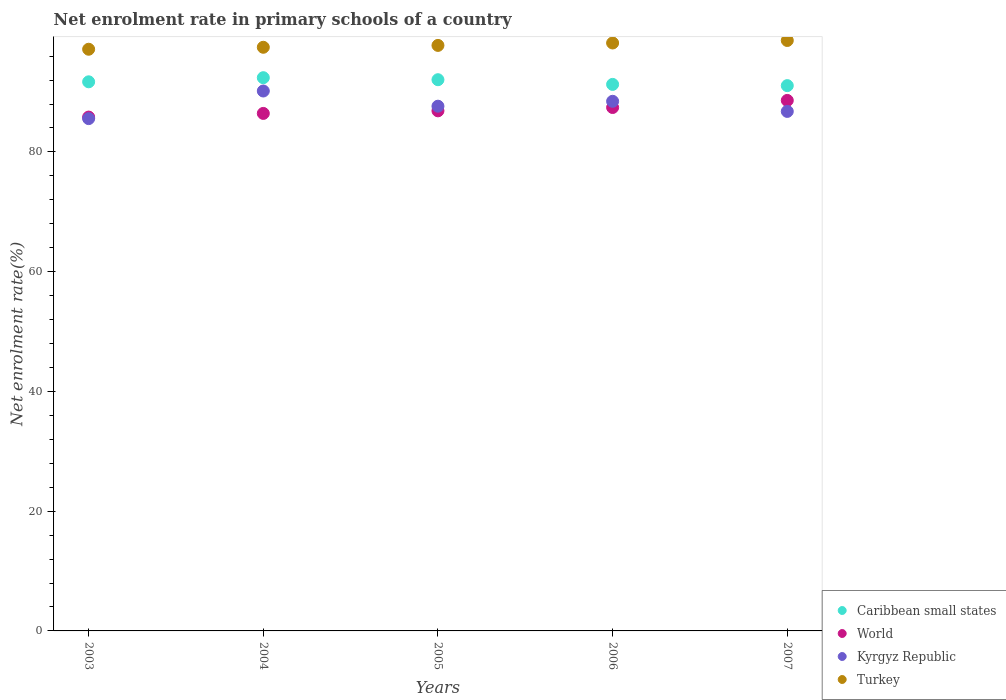How many different coloured dotlines are there?
Your answer should be compact. 4. Is the number of dotlines equal to the number of legend labels?
Provide a short and direct response. Yes. What is the net enrolment rate in primary schools in World in 2004?
Offer a terse response. 86.43. Across all years, what is the maximum net enrolment rate in primary schools in World?
Your answer should be very brief. 88.6. Across all years, what is the minimum net enrolment rate in primary schools in Kyrgyz Republic?
Give a very brief answer. 85.56. What is the total net enrolment rate in primary schools in World in the graph?
Offer a very short reply. 435.12. What is the difference between the net enrolment rate in primary schools in World in 2006 and that in 2007?
Offer a very short reply. -1.18. What is the difference between the net enrolment rate in primary schools in Kyrgyz Republic in 2003 and the net enrolment rate in primary schools in World in 2007?
Make the answer very short. -3.04. What is the average net enrolment rate in primary schools in Caribbean small states per year?
Ensure brevity in your answer.  91.7. In the year 2006, what is the difference between the net enrolment rate in primary schools in Turkey and net enrolment rate in primary schools in World?
Offer a very short reply. 10.78. What is the ratio of the net enrolment rate in primary schools in Caribbean small states in 2004 to that in 2007?
Keep it short and to the point. 1.01. What is the difference between the highest and the second highest net enrolment rate in primary schools in Kyrgyz Republic?
Offer a terse response. 1.72. What is the difference between the highest and the lowest net enrolment rate in primary schools in Caribbean small states?
Your response must be concise. 1.33. In how many years, is the net enrolment rate in primary schools in World greater than the average net enrolment rate in primary schools in World taken over all years?
Your answer should be very brief. 2. Is it the case that in every year, the sum of the net enrolment rate in primary schools in Caribbean small states and net enrolment rate in primary schools in Turkey  is greater than the net enrolment rate in primary schools in Kyrgyz Republic?
Provide a short and direct response. Yes. Does the net enrolment rate in primary schools in Caribbean small states monotonically increase over the years?
Provide a short and direct response. No. Is the net enrolment rate in primary schools in Turkey strictly greater than the net enrolment rate in primary schools in Kyrgyz Republic over the years?
Your response must be concise. Yes. Is the net enrolment rate in primary schools in Caribbean small states strictly less than the net enrolment rate in primary schools in World over the years?
Provide a succinct answer. No. How many years are there in the graph?
Offer a very short reply. 5. What is the difference between two consecutive major ticks on the Y-axis?
Keep it short and to the point. 20. Where does the legend appear in the graph?
Provide a short and direct response. Bottom right. How are the legend labels stacked?
Give a very brief answer. Vertical. What is the title of the graph?
Make the answer very short. Net enrolment rate in primary schools of a country. Does "World" appear as one of the legend labels in the graph?
Provide a short and direct response. Yes. What is the label or title of the Y-axis?
Provide a succinct answer. Net enrolment rate(%). What is the Net enrolment rate(%) of Caribbean small states in 2003?
Your answer should be very brief. 91.71. What is the Net enrolment rate(%) in World in 2003?
Offer a very short reply. 85.82. What is the Net enrolment rate(%) of Kyrgyz Republic in 2003?
Your answer should be very brief. 85.56. What is the Net enrolment rate(%) of Turkey in 2003?
Provide a short and direct response. 97.15. What is the Net enrolment rate(%) of Caribbean small states in 2004?
Provide a succinct answer. 92.4. What is the Net enrolment rate(%) in World in 2004?
Your answer should be very brief. 86.43. What is the Net enrolment rate(%) in Kyrgyz Republic in 2004?
Your response must be concise. 90.17. What is the Net enrolment rate(%) of Turkey in 2004?
Provide a succinct answer. 97.48. What is the Net enrolment rate(%) in Caribbean small states in 2005?
Provide a short and direct response. 92.06. What is the Net enrolment rate(%) of World in 2005?
Provide a succinct answer. 86.86. What is the Net enrolment rate(%) of Kyrgyz Republic in 2005?
Provide a succinct answer. 87.64. What is the Net enrolment rate(%) in Turkey in 2005?
Give a very brief answer. 97.79. What is the Net enrolment rate(%) of Caribbean small states in 2006?
Ensure brevity in your answer.  91.28. What is the Net enrolment rate(%) of World in 2006?
Offer a very short reply. 87.42. What is the Net enrolment rate(%) of Kyrgyz Republic in 2006?
Give a very brief answer. 88.45. What is the Net enrolment rate(%) of Turkey in 2006?
Offer a very short reply. 98.19. What is the Net enrolment rate(%) in Caribbean small states in 2007?
Your answer should be compact. 91.07. What is the Net enrolment rate(%) of World in 2007?
Your response must be concise. 88.6. What is the Net enrolment rate(%) in Kyrgyz Republic in 2007?
Offer a terse response. 86.76. What is the Net enrolment rate(%) of Turkey in 2007?
Provide a short and direct response. 98.61. Across all years, what is the maximum Net enrolment rate(%) in Caribbean small states?
Provide a short and direct response. 92.4. Across all years, what is the maximum Net enrolment rate(%) of World?
Your response must be concise. 88.6. Across all years, what is the maximum Net enrolment rate(%) of Kyrgyz Republic?
Provide a succinct answer. 90.17. Across all years, what is the maximum Net enrolment rate(%) in Turkey?
Ensure brevity in your answer.  98.61. Across all years, what is the minimum Net enrolment rate(%) of Caribbean small states?
Your answer should be very brief. 91.07. Across all years, what is the minimum Net enrolment rate(%) in World?
Your answer should be very brief. 85.82. Across all years, what is the minimum Net enrolment rate(%) in Kyrgyz Republic?
Your answer should be very brief. 85.56. Across all years, what is the minimum Net enrolment rate(%) of Turkey?
Offer a very short reply. 97.15. What is the total Net enrolment rate(%) of Caribbean small states in the graph?
Your response must be concise. 458.51. What is the total Net enrolment rate(%) in World in the graph?
Your answer should be very brief. 435.12. What is the total Net enrolment rate(%) of Kyrgyz Republic in the graph?
Your response must be concise. 438.59. What is the total Net enrolment rate(%) of Turkey in the graph?
Ensure brevity in your answer.  489.21. What is the difference between the Net enrolment rate(%) in Caribbean small states in 2003 and that in 2004?
Your answer should be compact. -0.69. What is the difference between the Net enrolment rate(%) of World in 2003 and that in 2004?
Provide a short and direct response. -0.61. What is the difference between the Net enrolment rate(%) in Kyrgyz Republic in 2003 and that in 2004?
Provide a succinct answer. -4.61. What is the difference between the Net enrolment rate(%) in Turkey in 2003 and that in 2004?
Make the answer very short. -0.33. What is the difference between the Net enrolment rate(%) in Caribbean small states in 2003 and that in 2005?
Provide a short and direct response. -0.35. What is the difference between the Net enrolment rate(%) of World in 2003 and that in 2005?
Make the answer very short. -1.04. What is the difference between the Net enrolment rate(%) of Kyrgyz Republic in 2003 and that in 2005?
Offer a very short reply. -2.08. What is the difference between the Net enrolment rate(%) in Turkey in 2003 and that in 2005?
Offer a terse response. -0.64. What is the difference between the Net enrolment rate(%) in Caribbean small states in 2003 and that in 2006?
Ensure brevity in your answer.  0.43. What is the difference between the Net enrolment rate(%) in World in 2003 and that in 2006?
Provide a succinct answer. -1.6. What is the difference between the Net enrolment rate(%) of Kyrgyz Republic in 2003 and that in 2006?
Offer a very short reply. -2.89. What is the difference between the Net enrolment rate(%) of Turkey in 2003 and that in 2006?
Offer a very short reply. -1.04. What is the difference between the Net enrolment rate(%) of Caribbean small states in 2003 and that in 2007?
Your response must be concise. 0.64. What is the difference between the Net enrolment rate(%) of World in 2003 and that in 2007?
Keep it short and to the point. -2.78. What is the difference between the Net enrolment rate(%) of Kyrgyz Republic in 2003 and that in 2007?
Provide a short and direct response. -1.21. What is the difference between the Net enrolment rate(%) in Turkey in 2003 and that in 2007?
Provide a succinct answer. -1.46. What is the difference between the Net enrolment rate(%) of Caribbean small states in 2004 and that in 2005?
Keep it short and to the point. 0.34. What is the difference between the Net enrolment rate(%) in World in 2004 and that in 2005?
Provide a short and direct response. -0.43. What is the difference between the Net enrolment rate(%) in Kyrgyz Republic in 2004 and that in 2005?
Your answer should be compact. 2.54. What is the difference between the Net enrolment rate(%) in Turkey in 2004 and that in 2005?
Provide a succinct answer. -0.31. What is the difference between the Net enrolment rate(%) of Caribbean small states in 2004 and that in 2006?
Provide a short and direct response. 1.12. What is the difference between the Net enrolment rate(%) in World in 2004 and that in 2006?
Provide a succinct answer. -0.99. What is the difference between the Net enrolment rate(%) in Kyrgyz Republic in 2004 and that in 2006?
Your answer should be very brief. 1.72. What is the difference between the Net enrolment rate(%) of Turkey in 2004 and that in 2006?
Your answer should be compact. -0.72. What is the difference between the Net enrolment rate(%) of Caribbean small states in 2004 and that in 2007?
Keep it short and to the point. 1.33. What is the difference between the Net enrolment rate(%) in World in 2004 and that in 2007?
Ensure brevity in your answer.  -2.17. What is the difference between the Net enrolment rate(%) of Kyrgyz Republic in 2004 and that in 2007?
Your answer should be compact. 3.41. What is the difference between the Net enrolment rate(%) of Turkey in 2004 and that in 2007?
Give a very brief answer. -1.14. What is the difference between the Net enrolment rate(%) of Caribbean small states in 2005 and that in 2006?
Keep it short and to the point. 0.78. What is the difference between the Net enrolment rate(%) of World in 2005 and that in 2006?
Give a very brief answer. -0.56. What is the difference between the Net enrolment rate(%) in Kyrgyz Republic in 2005 and that in 2006?
Your answer should be compact. -0.82. What is the difference between the Net enrolment rate(%) in Turkey in 2005 and that in 2006?
Ensure brevity in your answer.  -0.4. What is the difference between the Net enrolment rate(%) in World in 2005 and that in 2007?
Make the answer very short. -1.74. What is the difference between the Net enrolment rate(%) in Kyrgyz Republic in 2005 and that in 2007?
Offer a very short reply. 0.87. What is the difference between the Net enrolment rate(%) of Turkey in 2005 and that in 2007?
Provide a succinct answer. -0.82. What is the difference between the Net enrolment rate(%) in Caribbean small states in 2006 and that in 2007?
Your response must be concise. 0.21. What is the difference between the Net enrolment rate(%) in World in 2006 and that in 2007?
Keep it short and to the point. -1.18. What is the difference between the Net enrolment rate(%) in Kyrgyz Republic in 2006 and that in 2007?
Provide a succinct answer. 1.69. What is the difference between the Net enrolment rate(%) in Turkey in 2006 and that in 2007?
Offer a very short reply. -0.42. What is the difference between the Net enrolment rate(%) of Caribbean small states in 2003 and the Net enrolment rate(%) of World in 2004?
Offer a very short reply. 5.28. What is the difference between the Net enrolment rate(%) in Caribbean small states in 2003 and the Net enrolment rate(%) in Kyrgyz Republic in 2004?
Make the answer very short. 1.54. What is the difference between the Net enrolment rate(%) in Caribbean small states in 2003 and the Net enrolment rate(%) in Turkey in 2004?
Offer a very short reply. -5.77. What is the difference between the Net enrolment rate(%) in World in 2003 and the Net enrolment rate(%) in Kyrgyz Republic in 2004?
Your answer should be very brief. -4.35. What is the difference between the Net enrolment rate(%) in World in 2003 and the Net enrolment rate(%) in Turkey in 2004?
Your answer should be very brief. -11.66. What is the difference between the Net enrolment rate(%) in Kyrgyz Republic in 2003 and the Net enrolment rate(%) in Turkey in 2004?
Your response must be concise. -11.92. What is the difference between the Net enrolment rate(%) of Caribbean small states in 2003 and the Net enrolment rate(%) of World in 2005?
Make the answer very short. 4.85. What is the difference between the Net enrolment rate(%) in Caribbean small states in 2003 and the Net enrolment rate(%) in Kyrgyz Republic in 2005?
Offer a terse response. 4.07. What is the difference between the Net enrolment rate(%) of Caribbean small states in 2003 and the Net enrolment rate(%) of Turkey in 2005?
Give a very brief answer. -6.08. What is the difference between the Net enrolment rate(%) of World in 2003 and the Net enrolment rate(%) of Kyrgyz Republic in 2005?
Ensure brevity in your answer.  -1.82. What is the difference between the Net enrolment rate(%) in World in 2003 and the Net enrolment rate(%) in Turkey in 2005?
Keep it short and to the point. -11.97. What is the difference between the Net enrolment rate(%) of Kyrgyz Republic in 2003 and the Net enrolment rate(%) of Turkey in 2005?
Offer a very short reply. -12.23. What is the difference between the Net enrolment rate(%) of Caribbean small states in 2003 and the Net enrolment rate(%) of World in 2006?
Your answer should be compact. 4.29. What is the difference between the Net enrolment rate(%) of Caribbean small states in 2003 and the Net enrolment rate(%) of Kyrgyz Republic in 2006?
Your response must be concise. 3.26. What is the difference between the Net enrolment rate(%) of Caribbean small states in 2003 and the Net enrolment rate(%) of Turkey in 2006?
Give a very brief answer. -6.48. What is the difference between the Net enrolment rate(%) of World in 2003 and the Net enrolment rate(%) of Kyrgyz Republic in 2006?
Your answer should be very brief. -2.64. What is the difference between the Net enrolment rate(%) in World in 2003 and the Net enrolment rate(%) in Turkey in 2006?
Offer a terse response. -12.37. What is the difference between the Net enrolment rate(%) of Kyrgyz Republic in 2003 and the Net enrolment rate(%) of Turkey in 2006?
Offer a very short reply. -12.63. What is the difference between the Net enrolment rate(%) of Caribbean small states in 2003 and the Net enrolment rate(%) of World in 2007?
Offer a terse response. 3.11. What is the difference between the Net enrolment rate(%) of Caribbean small states in 2003 and the Net enrolment rate(%) of Kyrgyz Republic in 2007?
Provide a short and direct response. 4.94. What is the difference between the Net enrolment rate(%) of Caribbean small states in 2003 and the Net enrolment rate(%) of Turkey in 2007?
Provide a short and direct response. -6.9. What is the difference between the Net enrolment rate(%) of World in 2003 and the Net enrolment rate(%) of Kyrgyz Republic in 2007?
Provide a short and direct response. -0.95. What is the difference between the Net enrolment rate(%) in World in 2003 and the Net enrolment rate(%) in Turkey in 2007?
Your response must be concise. -12.79. What is the difference between the Net enrolment rate(%) in Kyrgyz Republic in 2003 and the Net enrolment rate(%) in Turkey in 2007?
Keep it short and to the point. -13.05. What is the difference between the Net enrolment rate(%) of Caribbean small states in 2004 and the Net enrolment rate(%) of World in 2005?
Make the answer very short. 5.54. What is the difference between the Net enrolment rate(%) in Caribbean small states in 2004 and the Net enrolment rate(%) in Kyrgyz Republic in 2005?
Provide a short and direct response. 4.76. What is the difference between the Net enrolment rate(%) in Caribbean small states in 2004 and the Net enrolment rate(%) in Turkey in 2005?
Provide a succinct answer. -5.39. What is the difference between the Net enrolment rate(%) of World in 2004 and the Net enrolment rate(%) of Kyrgyz Republic in 2005?
Keep it short and to the point. -1.21. What is the difference between the Net enrolment rate(%) in World in 2004 and the Net enrolment rate(%) in Turkey in 2005?
Your answer should be very brief. -11.36. What is the difference between the Net enrolment rate(%) of Kyrgyz Republic in 2004 and the Net enrolment rate(%) of Turkey in 2005?
Offer a very short reply. -7.62. What is the difference between the Net enrolment rate(%) in Caribbean small states in 2004 and the Net enrolment rate(%) in World in 2006?
Your answer should be very brief. 4.98. What is the difference between the Net enrolment rate(%) in Caribbean small states in 2004 and the Net enrolment rate(%) in Kyrgyz Republic in 2006?
Your response must be concise. 3.94. What is the difference between the Net enrolment rate(%) of Caribbean small states in 2004 and the Net enrolment rate(%) of Turkey in 2006?
Make the answer very short. -5.8. What is the difference between the Net enrolment rate(%) in World in 2004 and the Net enrolment rate(%) in Kyrgyz Republic in 2006?
Provide a succinct answer. -2.02. What is the difference between the Net enrolment rate(%) of World in 2004 and the Net enrolment rate(%) of Turkey in 2006?
Make the answer very short. -11.76. What is the difference between the Net enrolment rate(%) of Kyrgyz Republic in 2004 and the Net enrolment rate(%) of Turkey in 2006?
Your response must be concise. -8.02. What is the difference between the Net enrolment rate(%) of Caribbean small states in 2004 and the Net enrolment rate(%) of World in 2007?
Offer a very short reply. 3.8. What is the difference between the Net enrolment rate(%) in Caribbean small states in 2004 and the Net enrolment rate(%) in Kyrgyz Republic in 2007?
Make the answer very short. 5.63. What is the difference between the Net enrolment rate(%) in Caribbean small states in 2004 and the Net enrolment rate(%) in Turkey in 2007?
Offer a very short reply. -6.21. What is the difference between the Net enrolment rate(%) in World in 2004 and the Net enrolment rate(%) in Kyrgyz Republic in 2007?
Your answer should be very brief. -0.34. What is the difference between the Net enrolment rate(%) of World in 2004 and the Net enrolment rate(%) of Turkey in 2007?
Give a very brief answer. -12.18. What is the difference between the Net enrolment rate(%) in Kyrgyz Republic in 2004 and the Net enrolment rate(%) in Turkey in 2007?
Offer a terse response. -8.44. What is the difference between the Net enrolment rate(%) of Caribbean small states in 2005 and the Net enrolment rate(%) of World in 2006?
Ensure brevity in your answer.  4.64. What is the difference between the Net enrolment rate(%) in Caribbean small states in 2005 and the Net enrolment rate(%) in Kyrgyz Republic in 2006?
Offer a terse response. 3.61. What is the difference between the Net enrolment rate(%) in Caribbean small states in 2005 and the Net enrolment rate(%) in Turkey in 2006?
Provide a short and direct response. -6.13. What is the difference between the Net enrolment rate(%) of World in 2005 and the Net enrolment rate(%) of Kyrgyz Republic in 2006?
Make the answer very short. -1.59. What is the difference between the Net enrolment rate(%) in World in 2005 and the Net enrolment rate(%) in Turkey in 2006?
Offer a very short reply. -11.33. What is the difference between the Net enrolment rate(%) in Kyrgyz Republic in 2005 and the Net enrolment rate(%) in Turkey in 2006?
Provide a succinct answer. -10.56. What is the difference between the Net enrolment rate(%) of Caribbean small states in 2005 and the Net enrolment rate(%) of World in 2007?
Offer a terse response. 3.46. What is the difference between the Net enrolment rate(%) in Caribbean small states in 2005 and the Net enrolment rate(%) in Kyrgyz Republic in 2007?
Your answer should be very brief. 5.29. What is the difference between the Net enrolment rate(%) in Caribbean small states in 2005 and the Net enrolment rate(%) in Turkey in 2007?
Your answer should be compact. -6.55. What is the difference between the Net enrolment rate(%) in World in 2005 and the Net enrolment rate(%) in Kyrgyz Republic in 2007?
Your answer should be very brief. 0.1. What is the difference between the Net enrolment rate(%) of World in 2005 and the Net enrolment rate(%) of Turkey in 2007?
Offer a terse response. -11.75. What is the difference between the Net enrolment rate(%) in Kyrgyz Republic in 2005 and the Net enrolment rate(%) in Turkey in 2007?
Ensure brevity in your answer.  -10.97. What is the difference between the Net enrolment rate(%) in Caribbean small states in 2006 and the Net enrolment rate(%) in World in 2007?
Your response must be concise. 2.68. What is the difference between the Net enrolment rate(%) in Caribbean small states in 2006 and the Net enrolment rate(%) in Kyrgyz Republic in 2007?
Keep it short and to the point. 4.51. What is the difference between the Net enrolment rate(%) in Caribbean small states in 2006 and the Net enrolment rate(%) in Turkey in 2007?
Keep it short and to the point. -7.33. What is the difference between the Net enrolment rate(%) in World in 2006 and the Net enrolment rate(%) in Kyrgyz Republic in 2007?
Your answer should be compact. 0.65. What is the difference between the Net enrolment rate(%) in World in 2006 and the Net enrolment rate(%) in Turkey in 2007?
Keep it short and to the point. -11.19. What is the difference between the Net enrolment rate(%) in Kyrgyz Republic in 2006 and the Net enrolment rate(%) in Turkey in 2007?
Ensure brevity in your answer.  -10.16. What is the average Net enrolment rate(%) in Caribbean small states per year?
Keep it short and to the point. 91.7. What is the average Net enrolment rate(%) in World per year?
Offer a very short reply. 87.02. What is the average Net enrolment rate(%) of Kyrgyz Republic per year?
Provide a succinct answer. 87.72. What is the average Net enrolment rate(%) in Turkey per year?
Offer a very short reply. 97.84. In the year 2003, what is the difference between the Net enrolment rate(%) of Caribbean small states and Net enrolment rate(%) of World?
Offer a very short reply. 5.89. In the year 2003, what is the difference between the Net enrolment rate(%) of Caribbean small states and Net enrolment rate(%) of Kyrgyz Republic?
Provide a short and direct response. 6.15. In the year 2003, what is the difference between the Net enrolment rate(%) of Caribbean small states and Net enrolment rate(%) of Turkey?
Provide a succinct answer. -5.44. In the year 2003, what is the difference between the Net enrolment rate(%) in World and Net enrolment rate(%) in Kyrgyz Republic?
Give a very brief answer. 0.26. In the year 2003, what is the difference between the Net enrolment rate(%) of World and Net enrolment rate(%) of Turkey?
Your response must be concise. -11.33. In the year 2003, what is the difference between the Net enrolment rate(%) in Kyrgyz Republic and Net enrolment rate(%) in Turkey?
Ensure brevity in your answer.  -11.59. In the year 2004, what is the difference between the Net enrolment rate(%) in Caribbean small states and Net enrolment rate(%) in World?
Give a very brief answer. 5.97. In the year 2004, what is the difference between the Net enrolment rate(%) of Caribbean small states and Net enrolment rate(%) of Kyrgyz Republic?
Offer a very short reply. 2.22. In the year 2004, what is the difference between the Net enrolment rate(%) in Caribbean small states and Net enrolment rate(%) in Turkey?
Your answer should be very brief. -5.08. In the year 2004, what is the difference between the Net enrolment rate(%) in World and Net enrolment rate(%) in Kyrgyz Republic?
Offer a very short reply. -3.74. In the year 2004, what is the difference between the Net enrolment rate(%) in World and Net enrolment rate(%) in Turkey?
Give a very brief answer. -11.05. In the year 2004, what is the difference between the Net enrolment rate(%) in Kyrgyz Republic and Net enrolment rate(%) in Turkey?
Make the answer very short. -7.3. In the year 2005, what is the difference between the Net enrolment rate(%) of Caribbean small states and Net enrolment rate(%) of World?
Your answer should be compact. 5.2. In the year 2005, what is the difference between the Net enrolment rate(%) in Caribbean small states and Net enrolment rate(%) in Kyrgyz Republic?
Your answer should be compact. 4.42. In the year 2005, what is the difference between the Net enrolment rate(%) of Caribbean small states and Net enrolment rate(%) of Turkey?
Keep it short and to the point. -5.73. In the year 2005, what is the difference between the Net enrolment rate(%) of World and Net enrolment rate(%) of Kyrgyz Republic?
Offer a very short reply. -0.78. In the year 2005, what is the difference between the Net enrolment rate(%) in World and Net enrolment rate(%) in Turkey?
Provide a short and direct response. -10.93. In the year 2005, what is the difference between the Net enrolment rate(%) of Kyrgyz Republic and Net enrolment rate(%) of Turkey?
Provide a short and direct response. -10.15. In the year 2006, what is the difference between the Net enrolment rate(%) of Caribbean small states and Net enrolment rate(%) of World?
Offer a very short reply. 3.86. In the year 2006, what is the difference between the Net enrolment rate(%) in Caribbean small states and Net enrolment rate(%) in Kyrgyz Republic?
Ensure brevity in your answer.  2.82. In the year 2006, what is the difference between the Net enrolment rate(%) of Caribbean small states and Net enrolment rate(%) of Turkey?
Provide a short and direct response. -6.92. In the year 2006, what is the difference between the Net enrolment rate(%) of World and Net enrolment rate(%) of Kyrgyz Republic?
Your answer should be very brief. -1.04. In the year 2006, what is the difference between the Net enrolment rate(%) of World and Net enrolment rate(%) of Turkey?
Keep it short and to the point. -10.78. In the year 2006, what is the difference between the Net enrolment rate(%) of Kyrgyz Republic and Net enrolment rate(%) of Turkey?
Your answer should be very brief. -9.74. In the year 2007, what is the difference between the Net enrolment rate(%) of Caribbean small states and Net enrolment rate(%) of World?
Make the answer very short. 2.47. In the year 2007, what is the difference between the Net enrolment rate(%) of Caribbean small states and Net enrolment rate(%) of Kyrgyz Republic?
Offer a terse response. 4.31. In the year 2007, what is the difference between the Net enrolment rate(%) of Caribbean small states and Net enrolment rate(%) of Turkey?
Give a very brief answer. -7.54. In the year 2007, what is the difference between the Net enrolment rate(%) of World and Net enrolment rate(%) of Kyrgyz Republic?
Offer a very short reply. 1.83. In the year 2007, what is the difference between the Net enrolment rate(%) in World and Net enrolment rate(%) in Turkey?
Give a very brief answer. -10.01. In the year 2007, what is the difference between the Net enrolment rate(%) in Kyrgyz Republic and Net enrolment rate(%) in Turkey?
Your response must be concise. -11.85. What is the ratio of the Net enrolment rate(%) of Caribbean small states in 2003 to that in 2004?
Provide a succinct answer. 0.99. What is the ratio of the Net enrolment rate(%) of World in 2003 to that in 2004?
Give a very brief answer. 0.99. What is the ratio of the Net enrolment rate(%) of Kyrgyz Republic in 2003 to that in 2004?
Offer a terse response. 0.95. What is the ratio of the Net enrolment rate(%) in Turkey in 2003 to that in 2004?
Your answer should be compact. 1. What is the ratio of the Net enrolment rate(%) in Kyrgyz Republic in 2003 to that in 2005?
Your answer should be compact. 0.98. What is the ratio of the Net enrolment rate(%) in Turkey in 2003 to that in 2005?
Provide a succinct answer. 0.99. What is the ratio of the Net enrolment rate(%) of World in 2003 to that in 2006?
Keep it short and to the point. 0.98. What is the ratio of the Net enrolment rate(%) of Kyrgyz Republic in 2003 to that in 2006?
Make the answer very short. 0.97. What is the ratio of the Net enrolment rate(%) in Turkey in 2003 to that in 2006?
Keep it short and to the point. 0.99. What is the ratio of the Net enrolment rate(%) in World in 2003 to that in 2007?
Provide a short and direct response. 0.97. What is the ratio of the Net enrolment rate(%) in Kyrgyz Republic in 2003 to that in 2007?
Make the answer very short. 0.99. What is the ratio of the Net enrolment rate(%) in Turkey in 2003 to that in 2007?
Give a very brief answer. 0.99. What is the ratio of the Net enrolment rate(%) of Kyrgyz Republic in 2004 to that in 2005?
Offer a terse response. 1.03. What is the ratio of the Net enrolment rate(%) of Turkey in 2004 to that in 2005?
Offer a terse response. 1. What is the ratio of the Net enrolment rate(%) of Caribbean small states in 2004 to that in 2006?
Give a very brief answer. 1.01. What is the ratio of the Net enrolment rate(%) in World in 2004 to that in 2006?
Provide a short and direct response. 0.99. What is the ratio of the Net enrolment rate(%) in Kyrgyz Republic in 2004 to that in 2006?
Ensure brevity in your answer.  1.02. What is the ratio of the Net enrolment rate(%) of Caribbean small states in 2004 to that in 2007?
Keep it short and to the point. 1.01. What is the ratio of the Net enrolment rate(%) in World in 2004 to that in 2007?
Your response must be concise. 0.98. What is the ratio of the Net enrolment rate(%) in Kyrgyz Republic in 2004 to that in 2007?
Offer a terse response. 1.04. What is the ratio of the Net enrolment rate(%) in Caribbean small states in 2005 to that in 2006?
Provide a succinct answer. 1.01. What is the ratio of the Net enrolment rate(%) in World in 2005 to that in 2006?
Your answer should be compact. 0.99. What is the ratio of the Net enrolment rate(%) in Caribbean small states in 2005 to that in 2007?
Keep it short and to the point. 1.01. What is the ratio of the Net enrolment rate(%) in World in 2005 to that in 2007?
Give a very brief answer. 0.98. What is the ratio of the Net enrolment rate(%) of Kyrgyz Republic in 2005 to that in 2007?
Keep it short and to the point. 1.01. What is the ratio of the Net enrolment rate(%) of Turkey in 2005 to that in 2007?
Your answer should be very brief. 0.99. What is the ratio of the Net enrolment rate(%) of Caribbean small states in 2006 to that in 2007?
Offer a very short reply. 1. What is the ratio of the Net enrolment rate(%) of World in 2006 to that in 2007?
Make the answer very short. 0.99. What is the ratio of the Net enrolment rate(%) in Kyrgyz Republic in 2006 to that in 2007?
Ensure brevity in your answer.  1.02. What is the ratio of the Net enrolment rate(%) in Turkey in 2006 to that in 2007?
Offer a very short reply. 1. What is the difference between the highest and the second highest Net enrolment rate(%) in Caribbean small states?
Keep it short and to the point. 0.34. What is the difference between the highest and the second highest Net enrolment rate(%) of World?
Provide a short and direct response. 1.18. What is the difference between the highest and the second highest Net enrolment rate(%) of Kyrgyz Republic?
Your answer should be very brief. 1.72. What is the difference between the highest and the second highest Net enrolment rate(%) in Turkey?
Offer a very short reply. 0.42. What is the difference between the highest and the lowest Net enrolment rate(%) in Caribbean small states?
Provide a succinct answer. 1.33. What is the difference between the highest and the lowest Net enrolment rate(%) of World?
Your answer should be very brief. 2.78. What is the difference between the highest and the lowest Net enrolment rate(%) in Kyrgyz Republic?
Ensure brevity in your answer.  4.61. What is the difference between the highest and the lowest Net enrolment rate(%) in Turkey?
Provide a succinct answer. 1.46. 